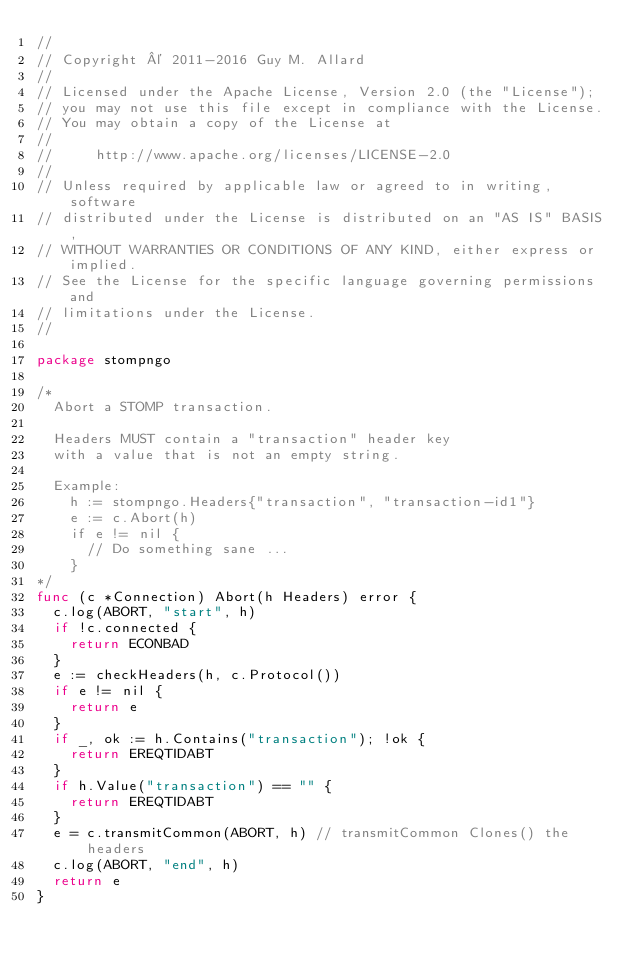<code> <loc_0><loc_0><loc_500><loc_500><_Go_>//
// Copyright © 2011-2016 Guy M. Allard
//
// Licensed under the Apache License, Version 2.0 (the "License");
// you may not use this file except in compliance with the License.
// You may obtain a copy of the License at
//
//     http://www.apache.org/licenses/LICENSE-2.0
//
// Unless required by applicable law or agreed to in writing, software
// distributed under the License is distributed on an "AS IS" BASIS,
// WITHOUT WARRANTIES OR CONDITIONS OF ANY KIND, either express or implied.
// See the License for the specific language governing permissions and
// limitations under the License.
//

package stompngo

/*
	Abort a STOMP transaction.

	Headers MUST contain a "transaction" header key
	with a value that is not an empty string.

	Example:
		h := stompngo.Headers{"transaction", "transaction-id1"}
		e := c.Abort(h)
		if e != nil {
			// Do something sane ...
		}
*/
func (c *Connection) Abort(h Headers) error {
	c.log(ABORT, "start", h)
	if !c.connected {
		return ECONBAD
	}
	e := checkHeaders(h, c.Protocol())
	if e != nil {
		return e
	}
	if _, ok := h.Contains("transaction"); !ok {
		return EREQTIDABT
	}
	if h.Value("transaction") == "" {
		return EREQTIDABT
	}
	e = c.transmitCommon(ABORT, h) // transmitCommon Clones() the headers
	c.log(ABORT, "end", h)
	return e
}
</code> 